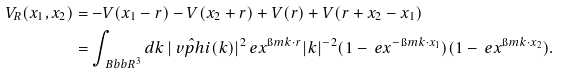<formula> <loc_0><loc_0><loc_500><loc_500>V _ { R } ( x _ { 1 } , x _ { 2 } ) & = - V ( x _ { 1 } - r ) - V ( x _ { 2 } + r ) + V ( r ) + V ( r + x _ { 2 } - x _ { 1 } ) \\ & = \int _ { \ B b b R ^ { 3 } } d k \, | \hat { \ v p h i } ( k ) | ^ { 2 } \ e x ^ { \i m k \cdot r } | k | ^ { - 2 } ( 1 - \ e x ^ { - \i m k \cdot x _ { 1 } } ) ( 1 - \ e x ^ { \i m k \cdot x _ { 2 } } ) .</formula> 